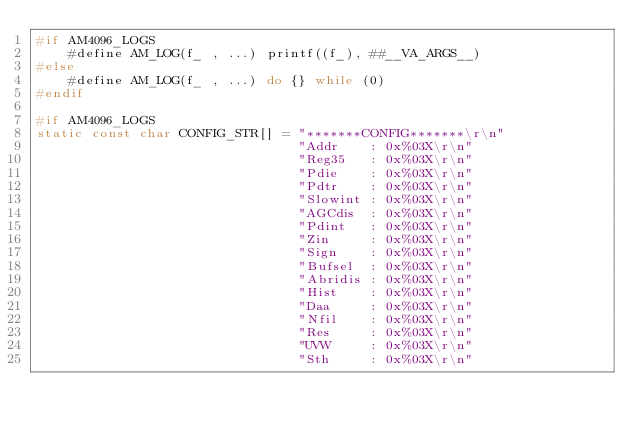Convert code to text. <code><loc_0><loc_0><loc_500><loc_500><_C++_>#if AM4096_LOGS
    #define AM_LOG(f_ , ...) printf((f_), ##__VA_ARGS__)
#else
    #define AM_LOG(f_ , ...) do {} while (0)
#endif

#if AM4096_LOGS
static const char CONFIG_STR[] = "*******CONFIG*******\r\n"
                                 "Addr    : 0x%03X\r\n"
                                 "Reg35   : 0x%03X\r\n"
                                 "Pdie    : 0x%03X\r\n"
                                 "Pdtr    : 0x%03X\r\n"
                                 "Slowint : 0x%03X\r\n"
                                 "AGCdis  : 0x%03X\r\n"
                                 "Pdint   : 0x%03X\r\n"
                                 "Zin     : 0x%03X\r\n"
                                 "Sign    : 0x%03X\r\n"
                                 "Bufsel  : 0x%03X\r\n"
                                 "Abridis : 0x%03X\r\n"
                                 "Hist    : 0x%03X\r\n"
                                 "Daa     : 0x%03X\r\n"
                                 "Nfil    : 0x%03X\r\n"
                                 "Res     : 0x%03X\r\n"
                                 "UVW     : 0x%03X\r\n"
                                 "Sth     : 0x%03X\r\n"</code> 